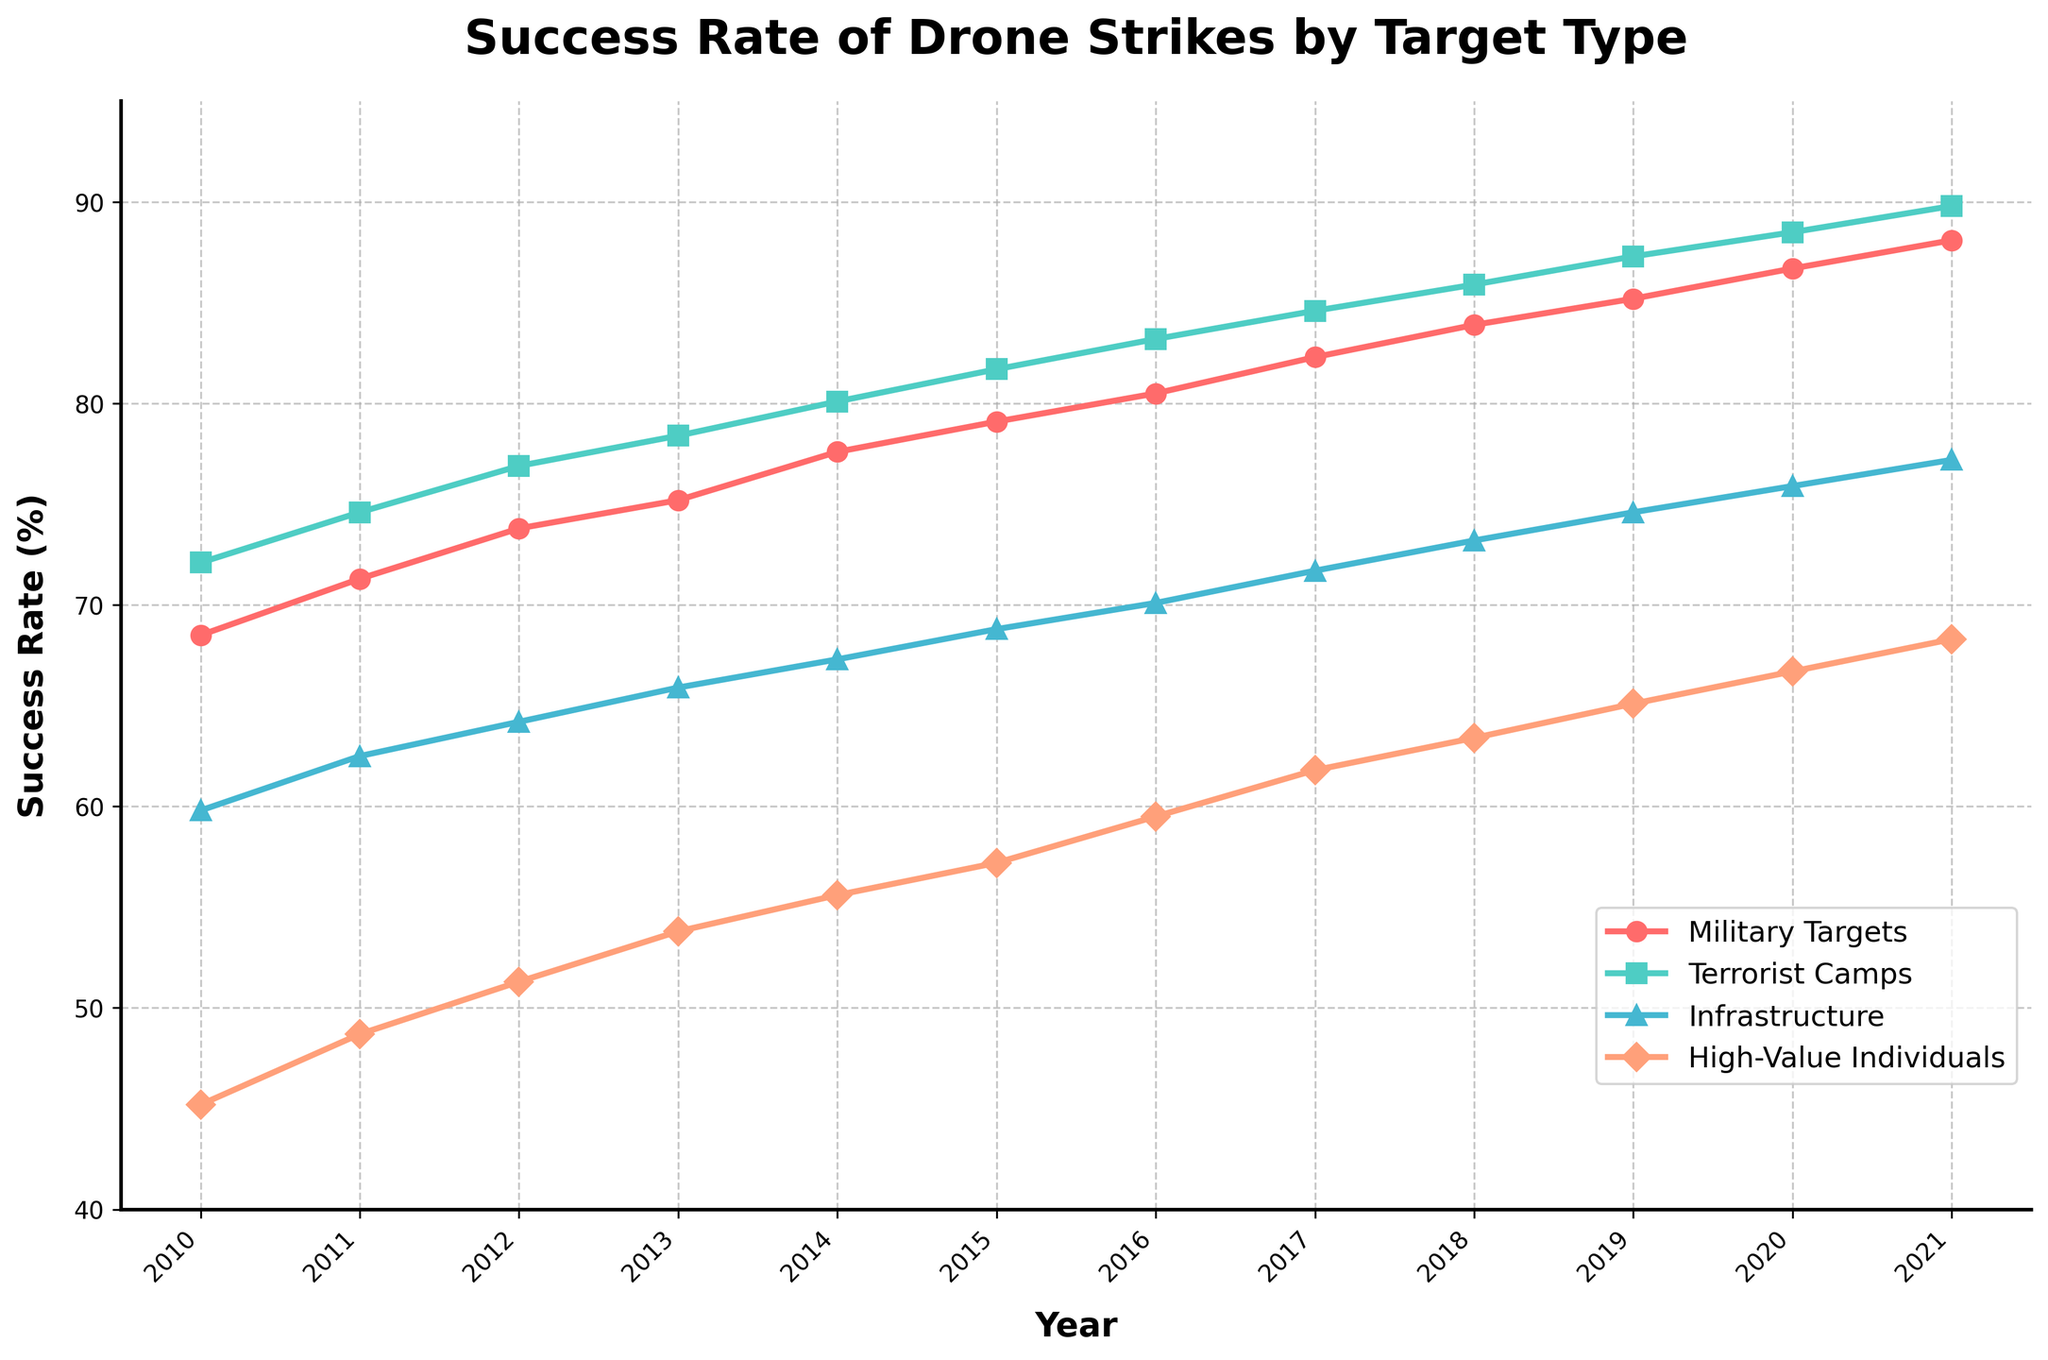Which year had the highest success rate for Infrastructure targets? The line representing Infrastructure targets (light blue) peaks at 2021 with the highest value on the y-axis.
Answer: 2021 Compare the success rates of Military Targets and High-Value Individuals in 2013. How much higher is one than the other? In 2013, the success rate for Military Targets (red) is 75.2% and for High-Value Individuals (orange) is 53.8%. The difference is 75.2% - 53.8% = 21.4%.
Answer: 21.4% What is the average success rate of Terrorist Camps over the data period? Sum the success rates for Terrorist Camps (green) from 2010 to 2021 and divide by the number of years: (72.1 + 74.6 + 76.9 + 78.4 + 80.1 + 81.7 + 83.2 + 84.6 + 85.9 + 87.3 + 88.5 + 89.8) / 12 = 81.16%.
Answer: 81.16% Which year shows the steepest increase in success rate for Military Targets? The steepest increase can be found by observing the greatest rise between consecutive years. From 2016 to 2017, the success rate rises from 80.5% to 82.3%, an increase of 1.8%, which is the steepest rise.
Answer: 2017 In which years did the success rate for High-Value Individuals exceed 60%? The line representing High-Value Individuals (orange) exceeds 60% starting in 2017 and continues to do so in subsequent years up until 2021.
Answer: 2017-2021 How does the success rate of Military Targets in 2015 compare to that in 2020? The success rate for Military Targets in 2015 is 79.1%, while in 2020 it is 86.7%. Comparing both, 86.7% - 79.1% equals an increase of 7.6%.
Answer: 7.6% Between which consecutive years does Infantry structure have the smallest increase in success rate? Observing the rate changes for Infrastructure (light blue) between each year, the smallest increase is between 2012 and 2013, where it changes from 64.2% to 65.9%, an increase of 1.7%.
Answer: 2013 